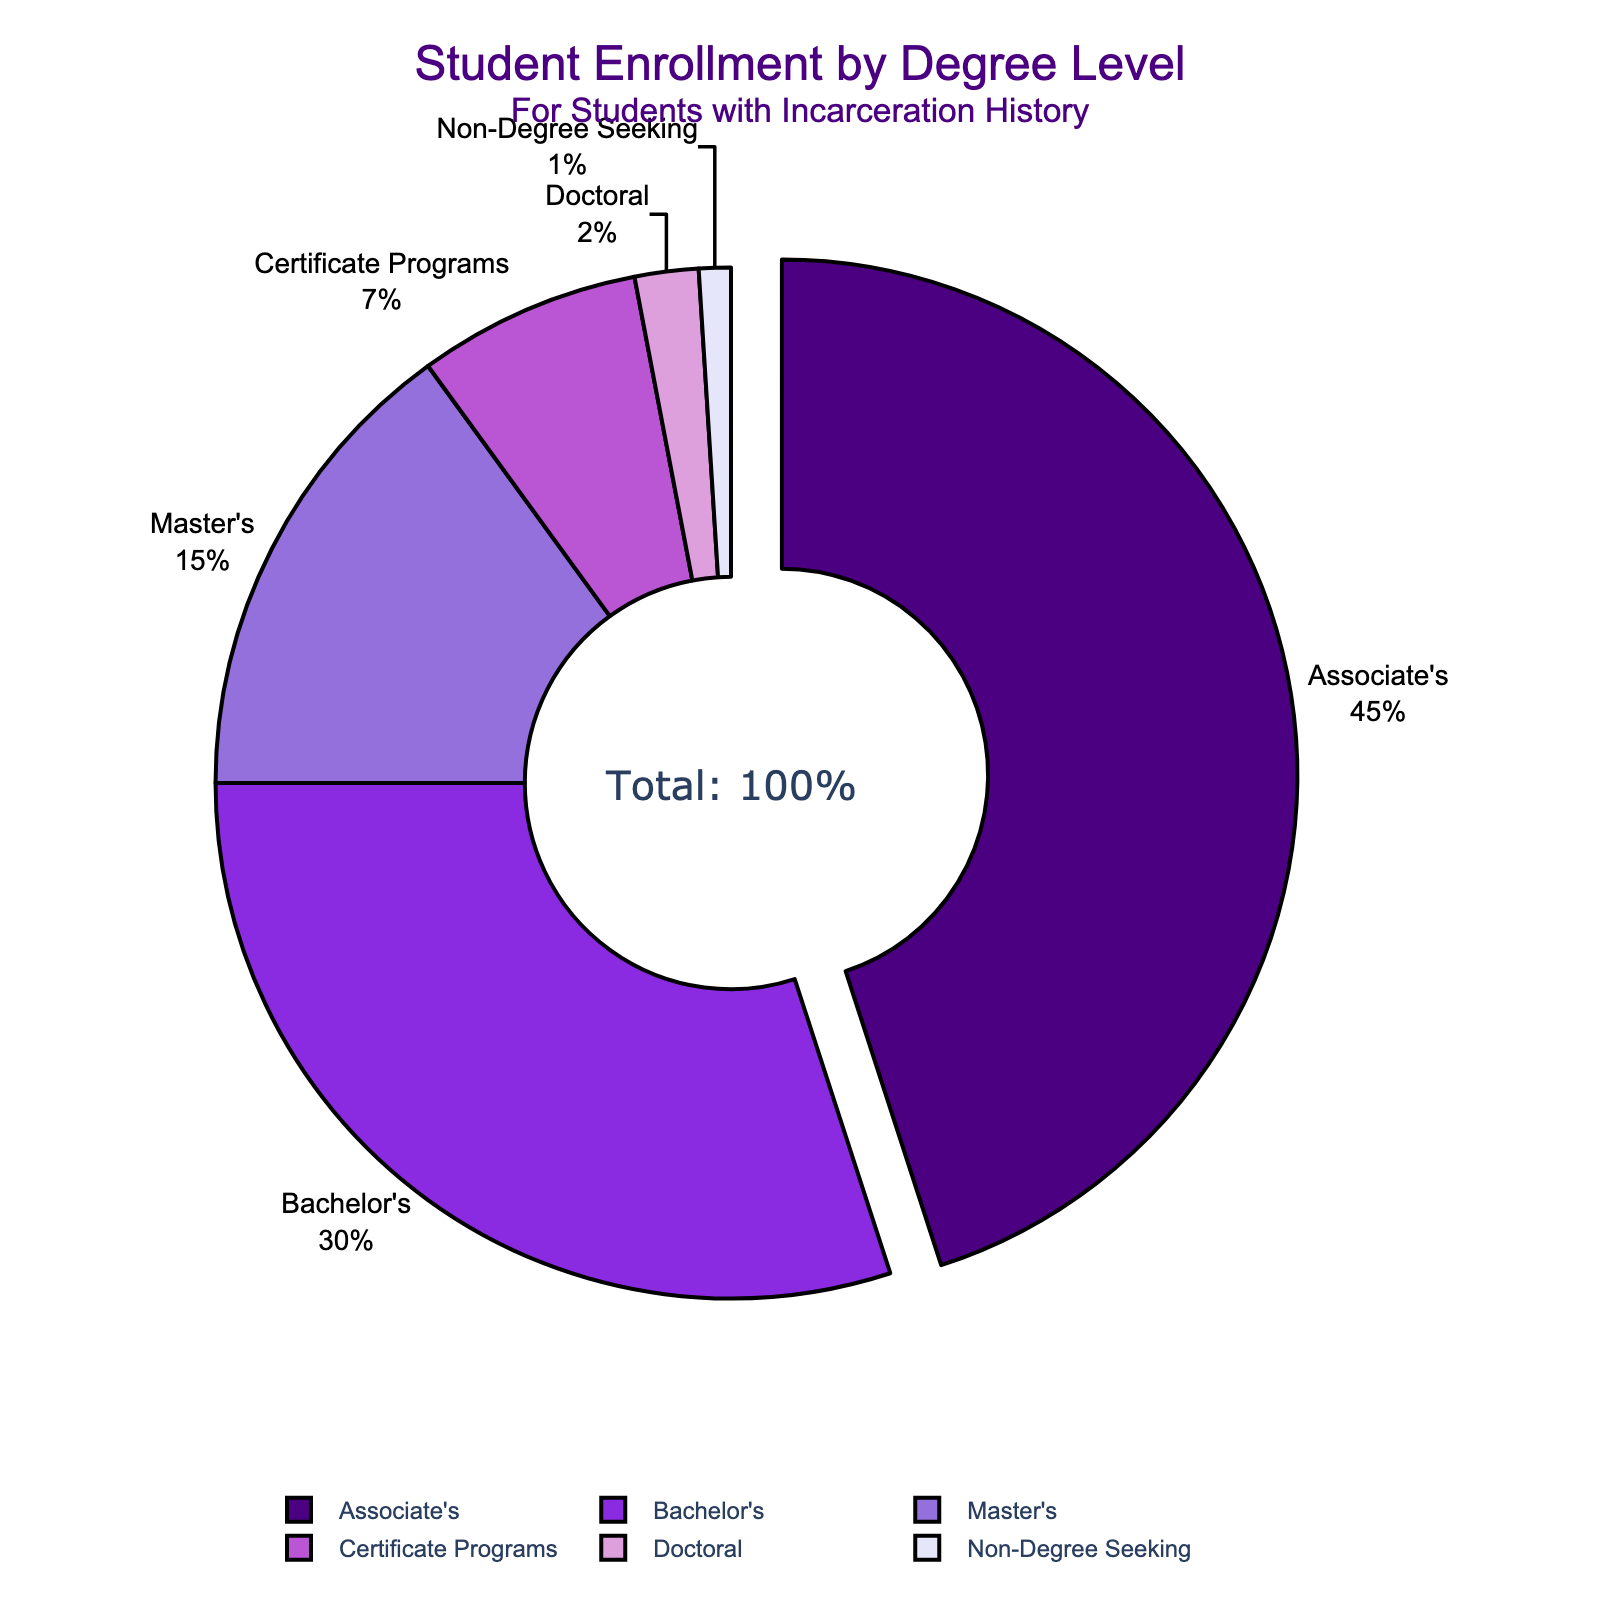Which degree level has the highest enrollment percentage among students with a history of incarceration? The pie chart shows that the Associate's degree level has the highest percentage. This section is visually highlighted by being pulled out slightly from the rest of the pie.
Answer: Associate's, 45% What is the total percentage of students with a history of incarceration enrolled in bachelor's and master's programs combined? The Bachelor's program has 30% and the Master's program has 15%. Adding these gives 30% + 15% = 45%.
Answer: 45% Which degree level has the smallest enrollment percentage? According to the pie chart, the Non-Degree Seeking section has the smallest percentage, which is labeled as 1%.
Answer: Non-Degree Seeking, 1% How does the enrollment percentage in doctoral programs compare to certificate programs? The enrollment percentage in doctoral programs is 2%, while in certificate programs it is 7%. 2% is less than 7%.
Answer: 2% < 7% What visual feature is used to emphasize the degree level with the highest percentage? The chart visually emphasizes the degree level with the highest percentage by pulling out the corresponding pie slice slightly from the rest of the chart.
Answer: Pulled out pie slice What is the total percentage of students enrolled in different types of degree programs excluding the Associate's degree level? Summing up the percentages of Bachelor's (30%), Master's (15%), Certificate Programs (7%), Doctoral (2%), and Non-Degree Seeking (1%) gives 55%.
Answer: 55% What is the second most common degree level for students with a history of incarceration? The pie chart shows that the Bachelor's degree level follows the Associate's degree as the next largest section.
Answer: Bachelor's, 30% How does the percentage of Master's enrolment compare to Non-Degree Seeking enrolment? The Master's enrolment is 15%, and the Non-Degree Seeking enrolment is 1%. 15% is much larger than 1%.
Answer: 15% > 1% If we combine the percentages of Certificate Programs, Doctoral, and Non-Degree Seeking students, what percentage do we get? Adding the percentages of Certificate Programs (7%), Doctoral (2%), and Non-Degree Seeking (1%) gives 7% + 2% + 1% = 10%.
Answer: 10% 